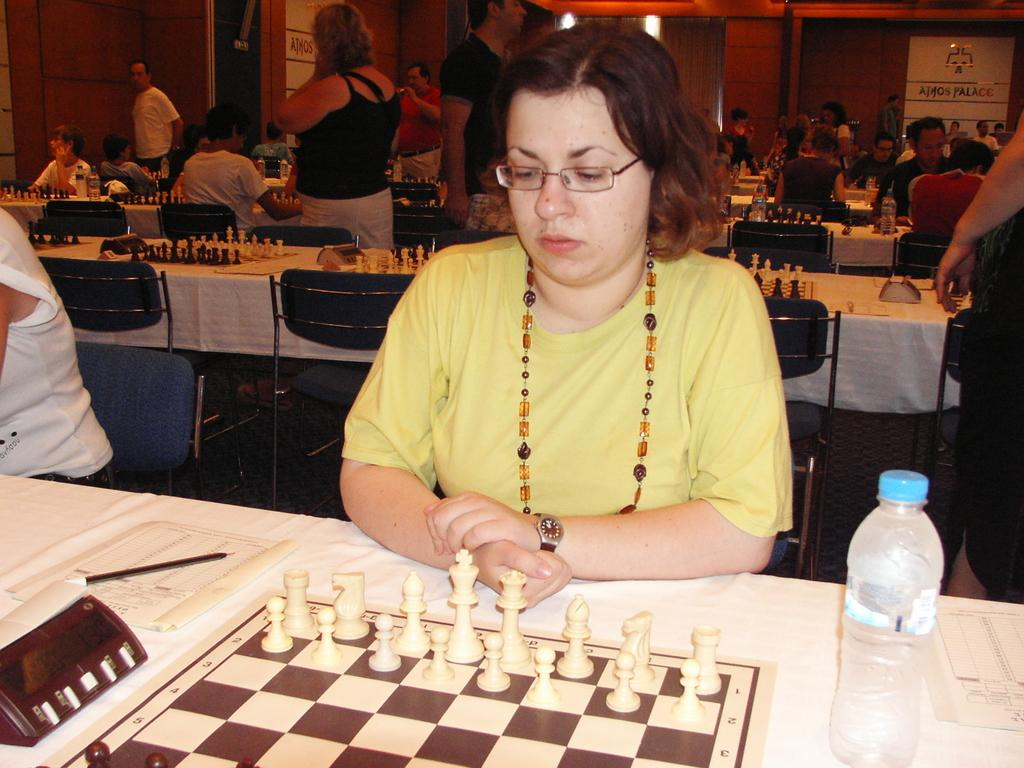What are the people in the image doing? There are people sitting on chairs and standing in the image. What furniture is visible in the image? Tables and chairs are visible in the image. What objects can be seen on the tables? There is a chess set, a book, a pen, and a bottle on the tables. What can be seen in the background of the image? There is a wall visible in the background. Reasoning: Let's think step by step by breaking down the image into its main components. We start by identifying the people and their actions, such as sitting and standing. Then, we describe the furniture and objects present in the image, focusing on the tables and their contents. Finally, we mention the background element, which is the wall. Absurd Question/Answer: What type of feast is being prepared in the image? There is no indication of a feast being prepared in the image; it features people sitting or standing around tables with various objects on them. Can you see any fog in the image? There is no fog visible in the image; it is an indoor scene with a clear background. 